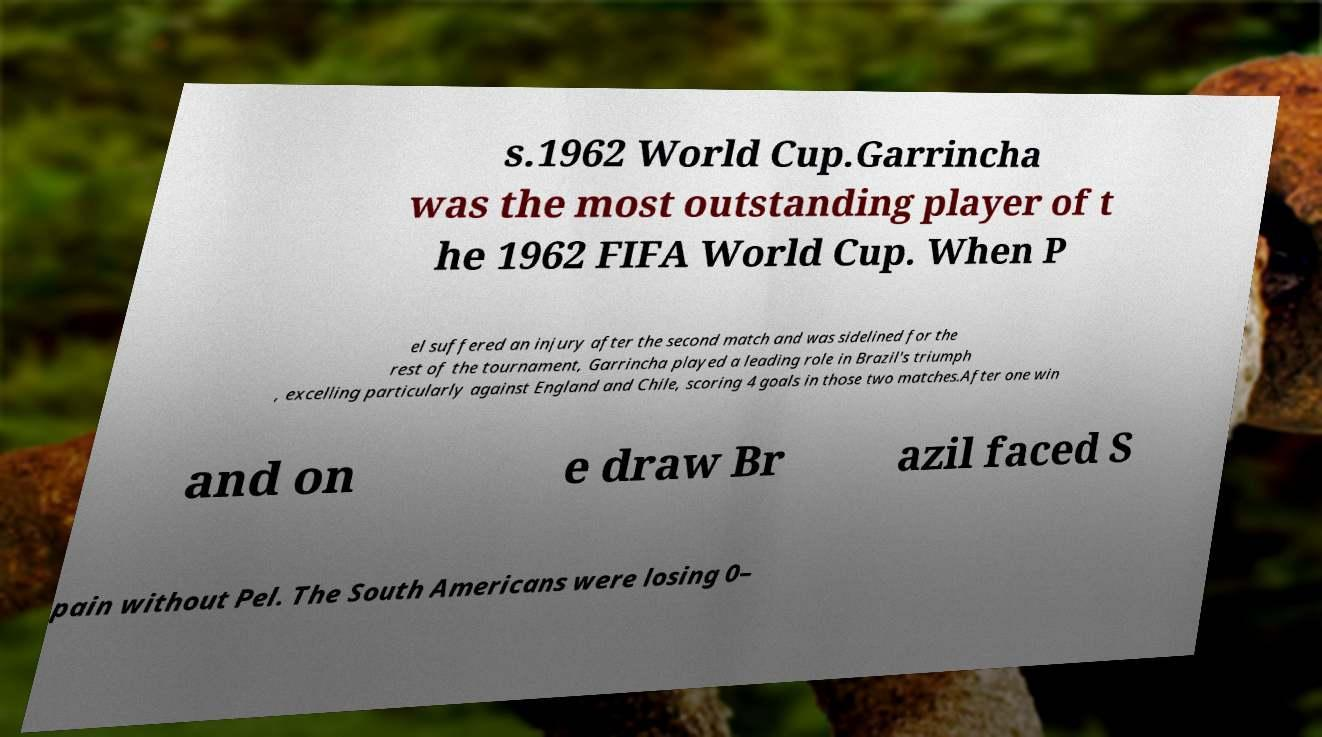Can you read and provide the text displayed in the image?This photo seems to have some interesting text. Can you extract and type it out for me? s.1962 World Cup.Garrincha was the most outstanding player of t he 1962 FIFA World Cup. When P el suffered an injury after the second match and was sidelined for the rest of the tournament, Garrincha played a leading role in Brazil's triumph , excelling particularly against England and Chile, scoring 4 goals in those two matches.After one win and on e draw Br azil faced S pain without Pel. The South Americans were losing 0– 